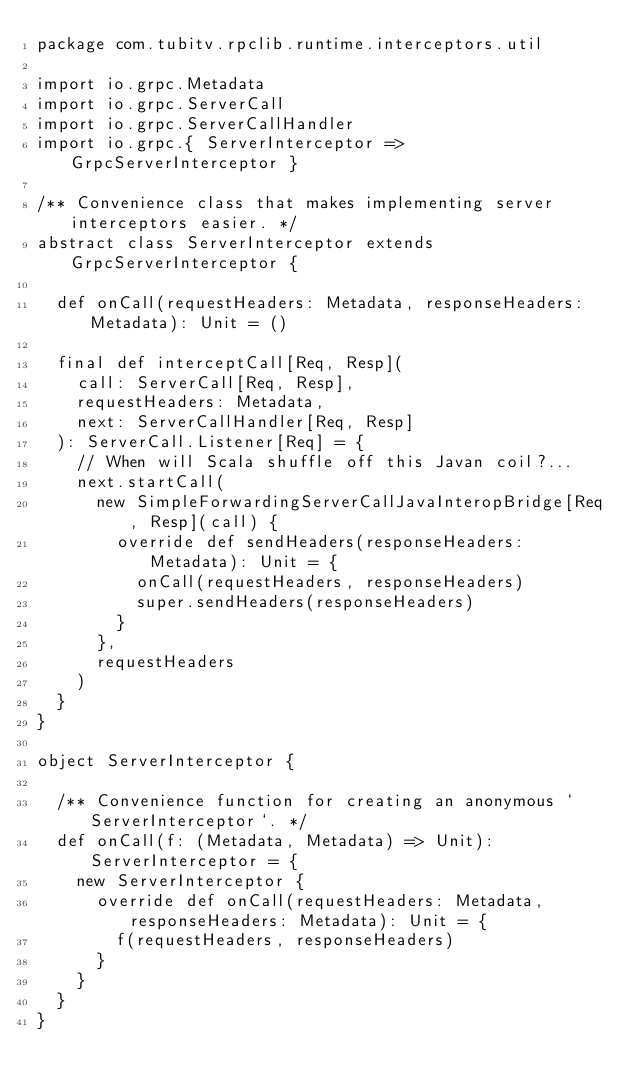<code> <loc_0><loc_0><loc_500><loc_500><_Scala_>package com.tubitv.rpclib.runtime.interceptors.util

import io.grpc.Metadata
import io.grpc.ServerCall
import io.grpc.ServerCallHandler
import io.grpc.{ ServerInterceptor => GrpcServerInterceptor }

/** Convenience class that makes implementing server interceptors easier. */
abstract class ServerInterceptor extends GrpcServerInterceptor {

  def onCall(requestHeaders: Metadata, responseHeaders: Metadata): Unit = ()

  final def interceptCall[Req, Resp](
    call: ServerCall[Req, Resp],
    requestHeaders: Metadata,
    next: ServerCallHandler[Req, Resp]
  ): ServerCall.Listener[Req] = {
    // When will Scala shuffle off this Javan coil?...
    next.startCall(
      new SimpleForwardingServerCallJavaInteropBridge[Req, Resp](call) {
        override def sendHeaders(responseHeaders: Metadata): Unit = {
          onCall(requestHeaders, responseHeaders)
          super.sendHeaders(responseHeaders)
        }
      },
      requestHeaders
    )
  }
}

object ServerInterceptor {

  /** Convenience function for creating an anonymous `ServerInterceptor`. */
  def onCall(f: (Metadata, Metadata) => Unit): ServerInterceptor = {
    new ServerInterceptor {
      override def onCall(requestHeaders: Metadata, responseHeaders: Metadata): Unit = {
        f(requestHeaders, responseHeaders)
      }
    }
  }
}
</code> 